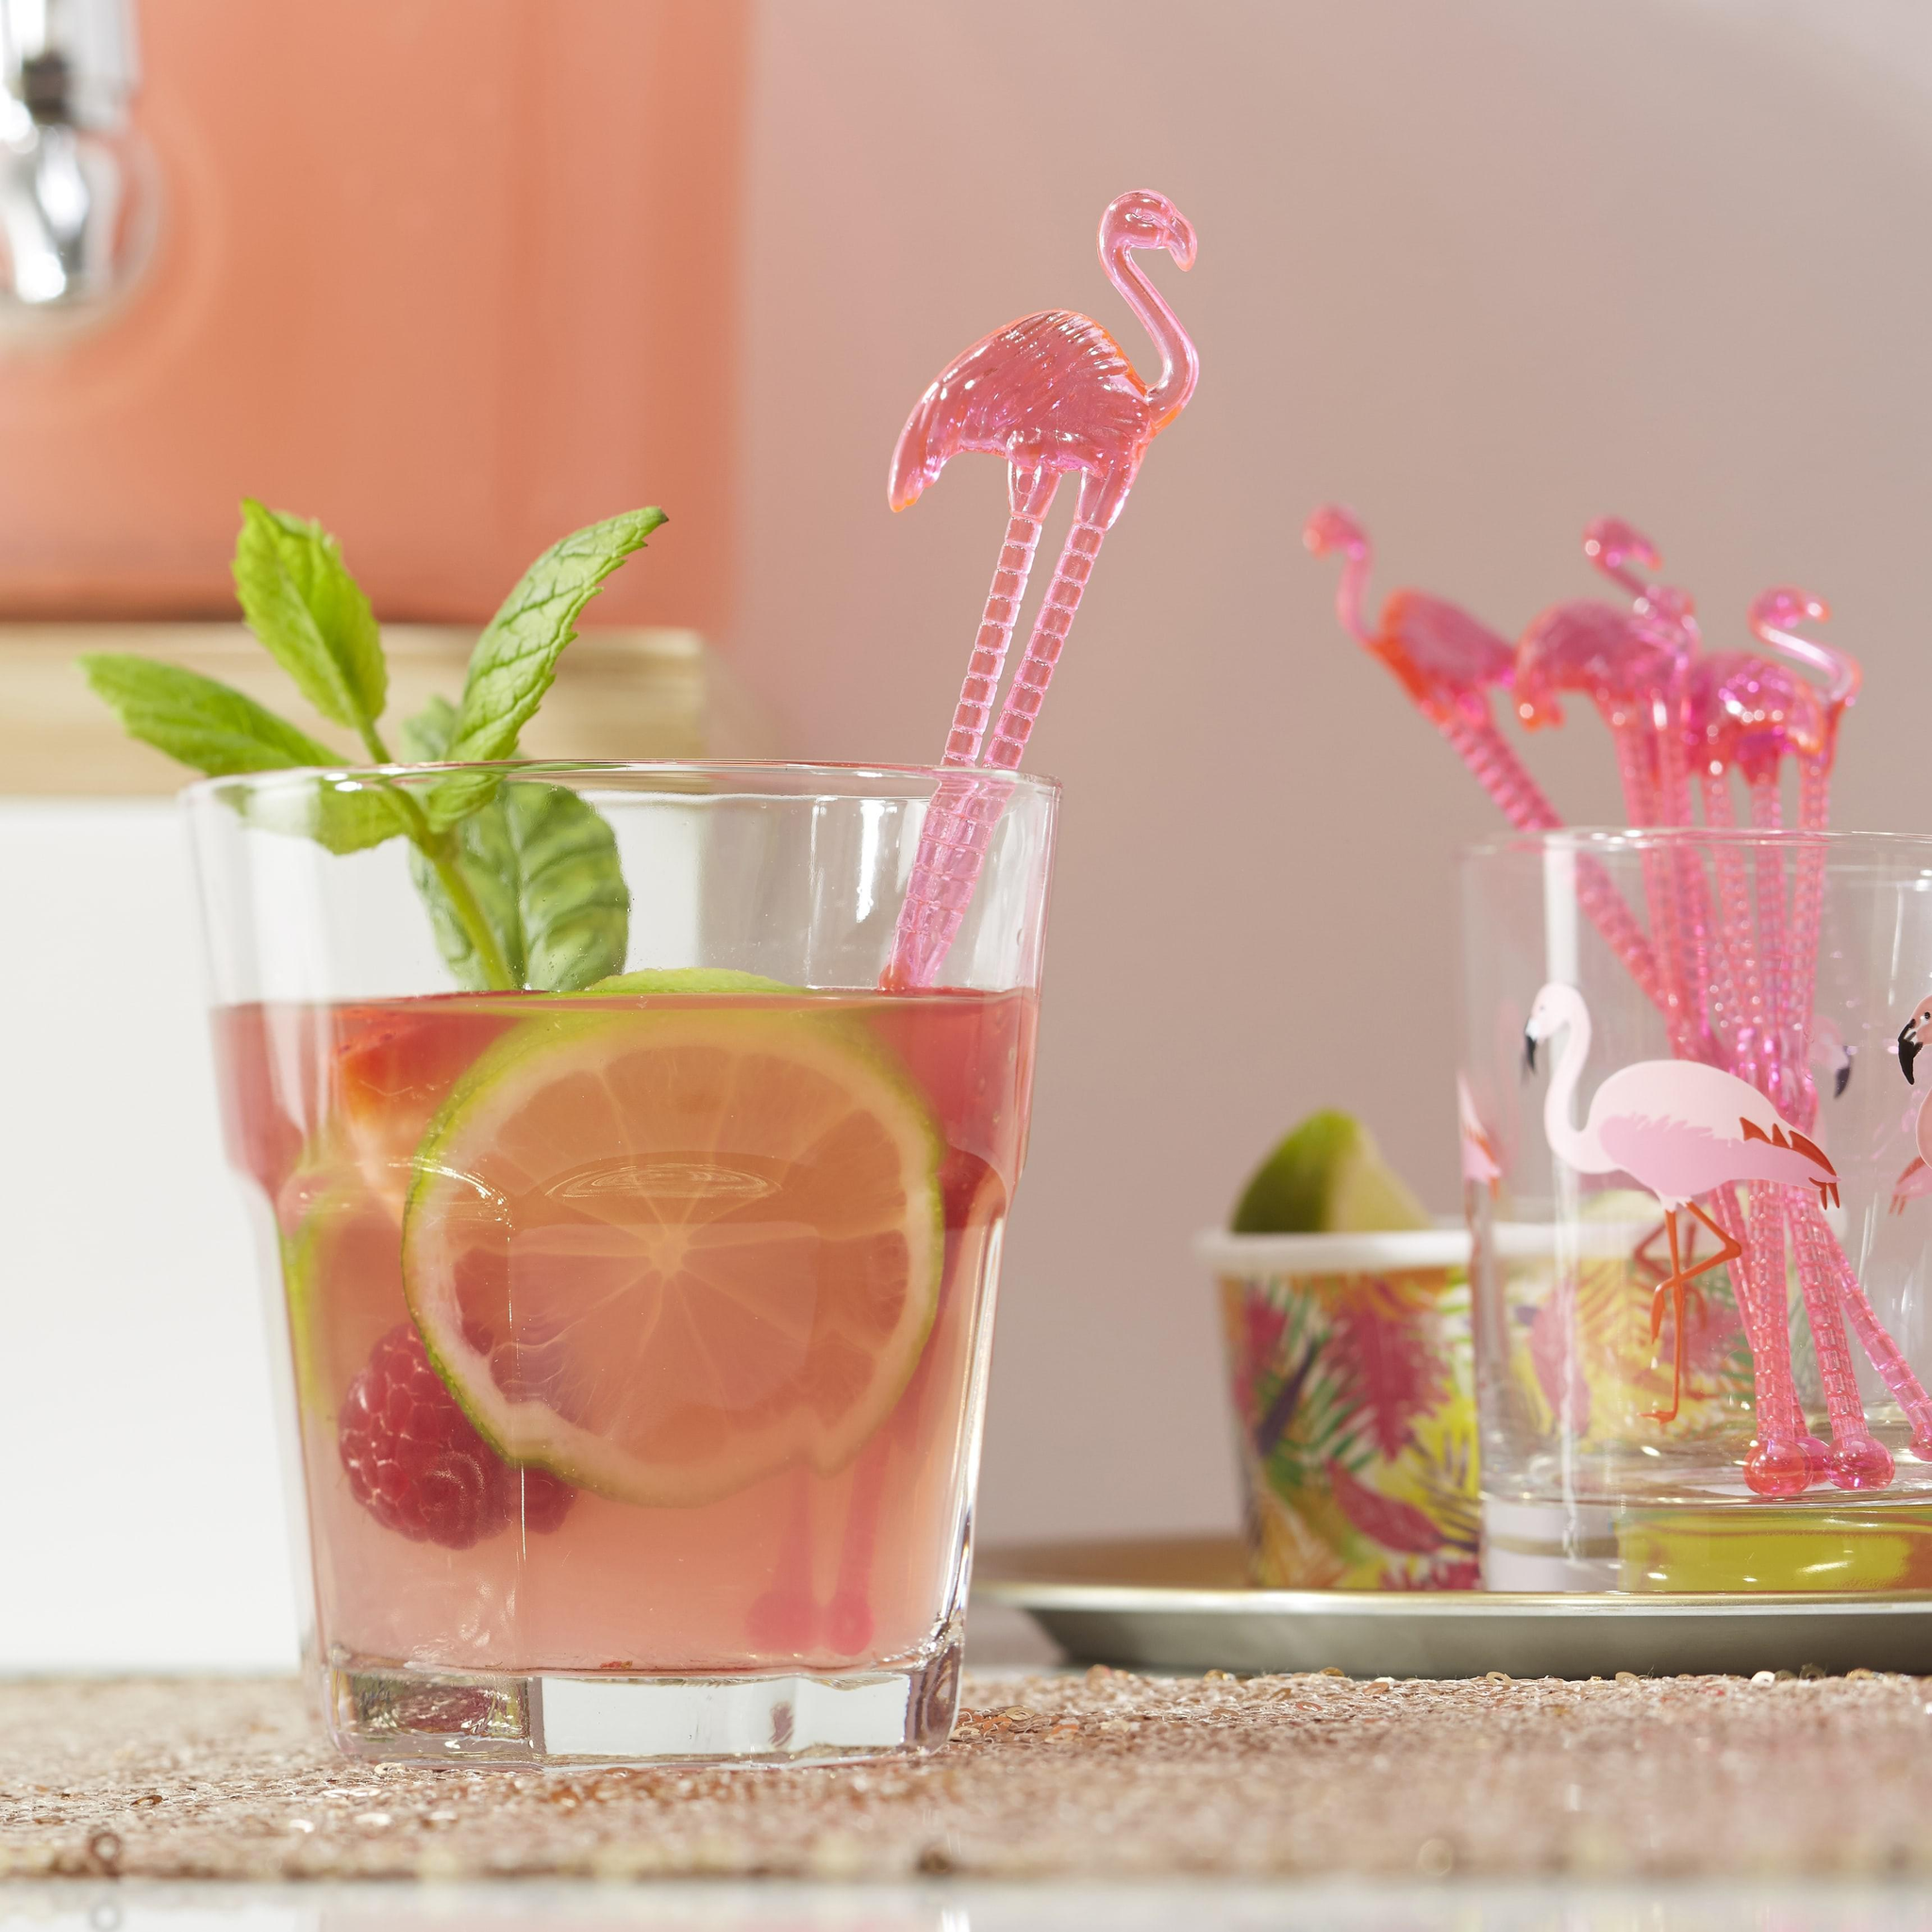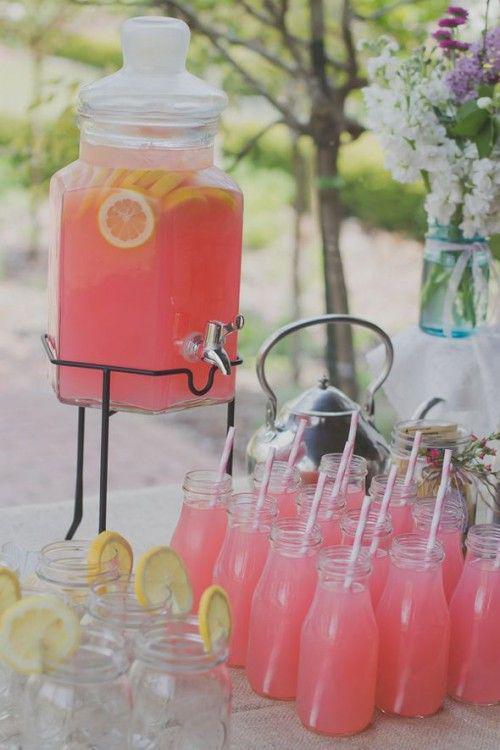The first image is the image on the left, the second image is the image on the right. Analyze the images presented: Is the assertion "Both images have pink lemonade in glass dishes." valid? Answer yes or no. Yes. The first image is the image on the left, the second image is the image on the right. Assess this claim about the two images: "There are straws in the right image.". Correct or not? Answer yes or no. Yes. 